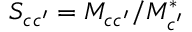<formula> <loc_0><loc_0><loc_500><loc_500>S _ { c c ^ { \prime } } = { M } _ { c c ^ { \prime } } / { M } _ { c ^ { \prime } } ^ { * }</formula> 